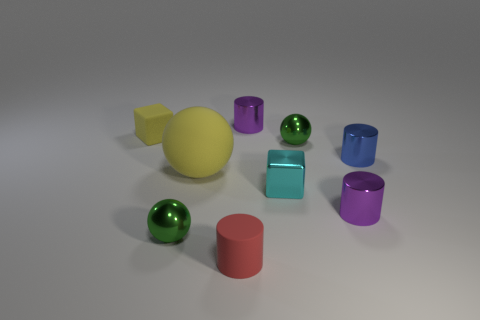Subtract all spheres. How many objects are left? 6 Add 3 balls. How many balls are left? 6 Add 8 small green metal cylinders. How many small green metal cylinders exist? 8 Subtract 0 yellow cylinders. How many objects are left? 9 Subtract all purple cylinders. Subtract all small metal objects. How many objects are left? 1 